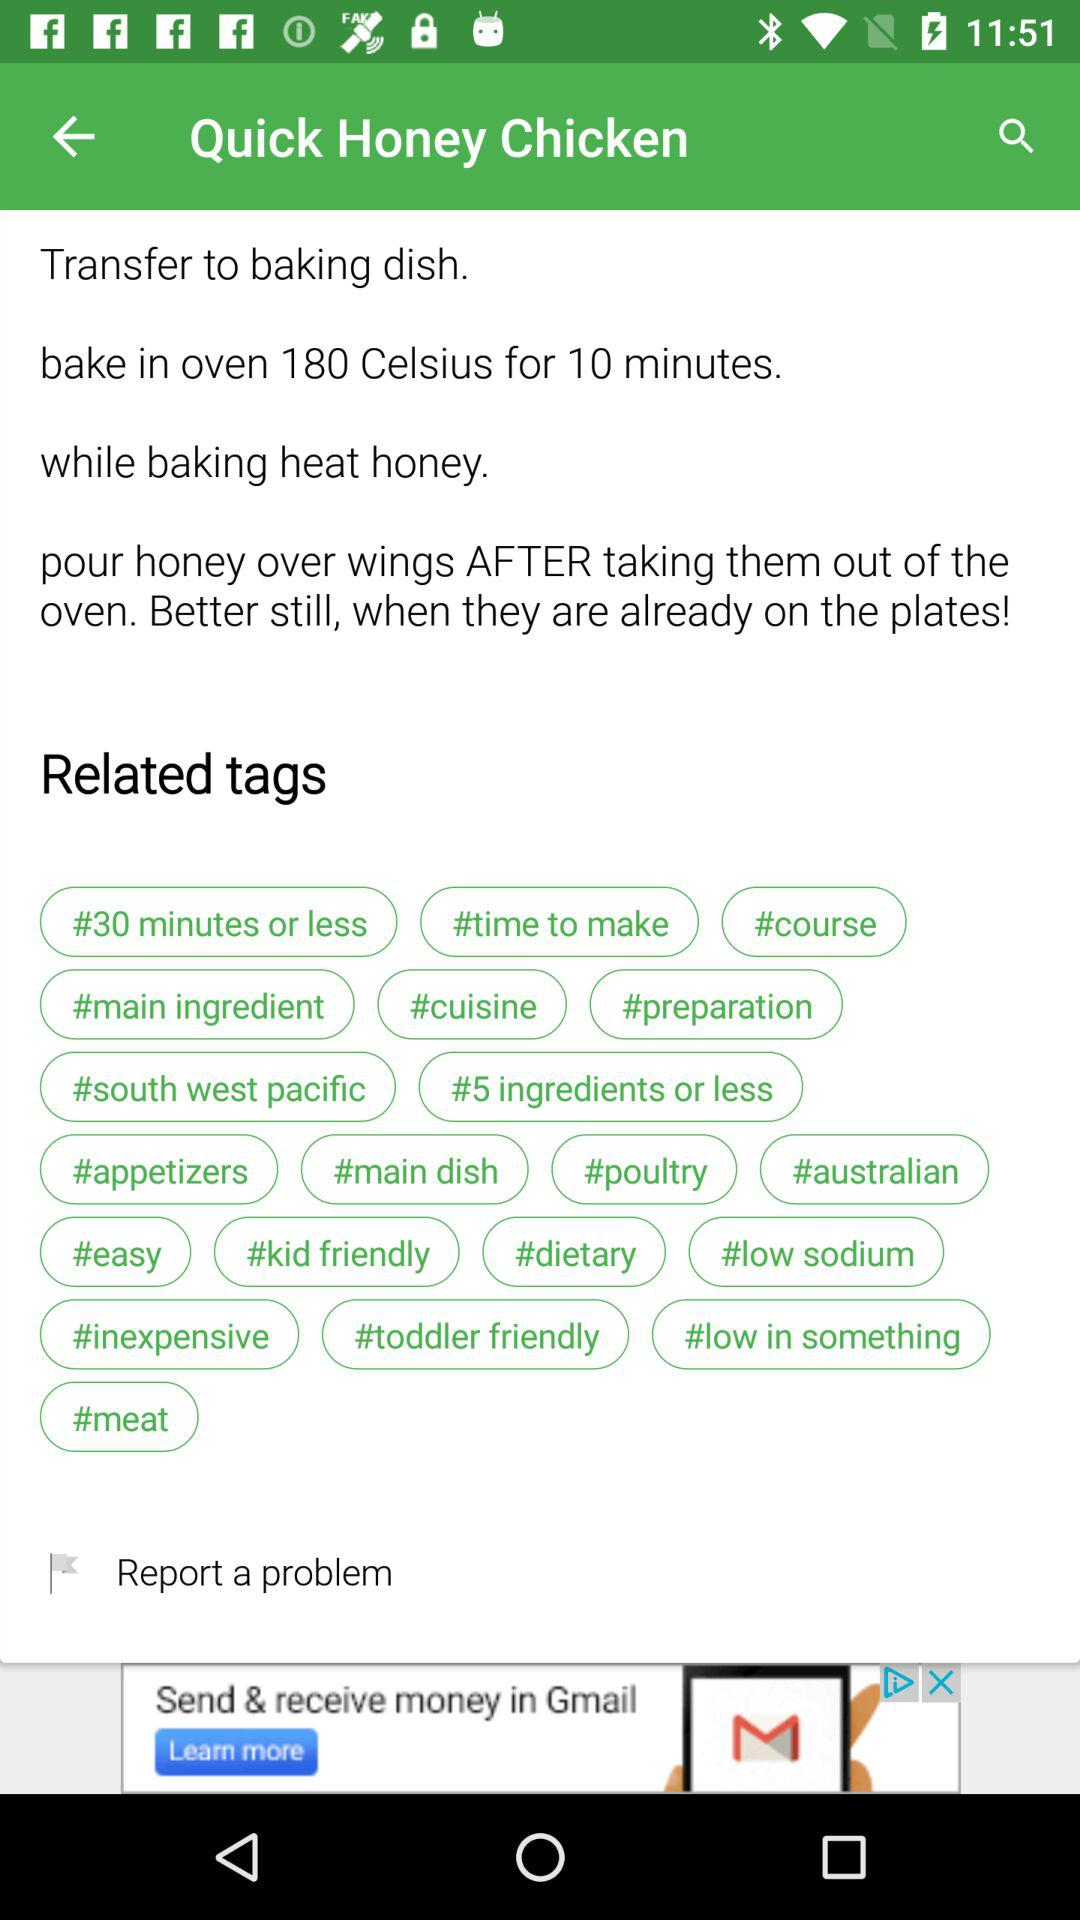What should be the temperature for baking? The temperature for baking should be 180 °C. 